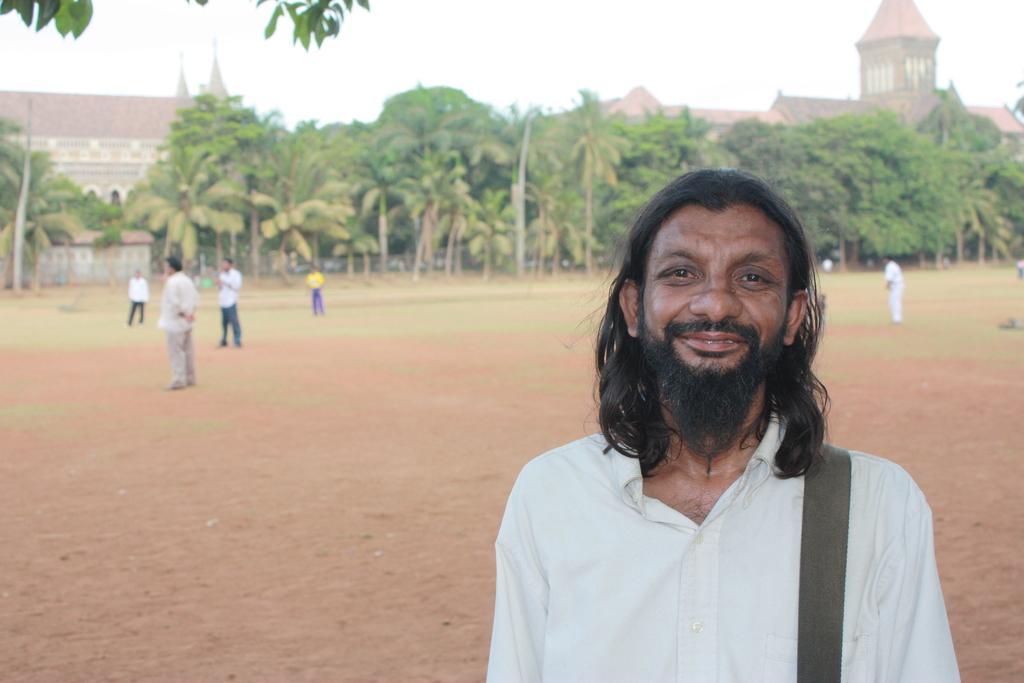Describe this image in one or two sentences. In this image, there are a few people. We can see the ground. We can see some grass and trees. We can also see the sky. 